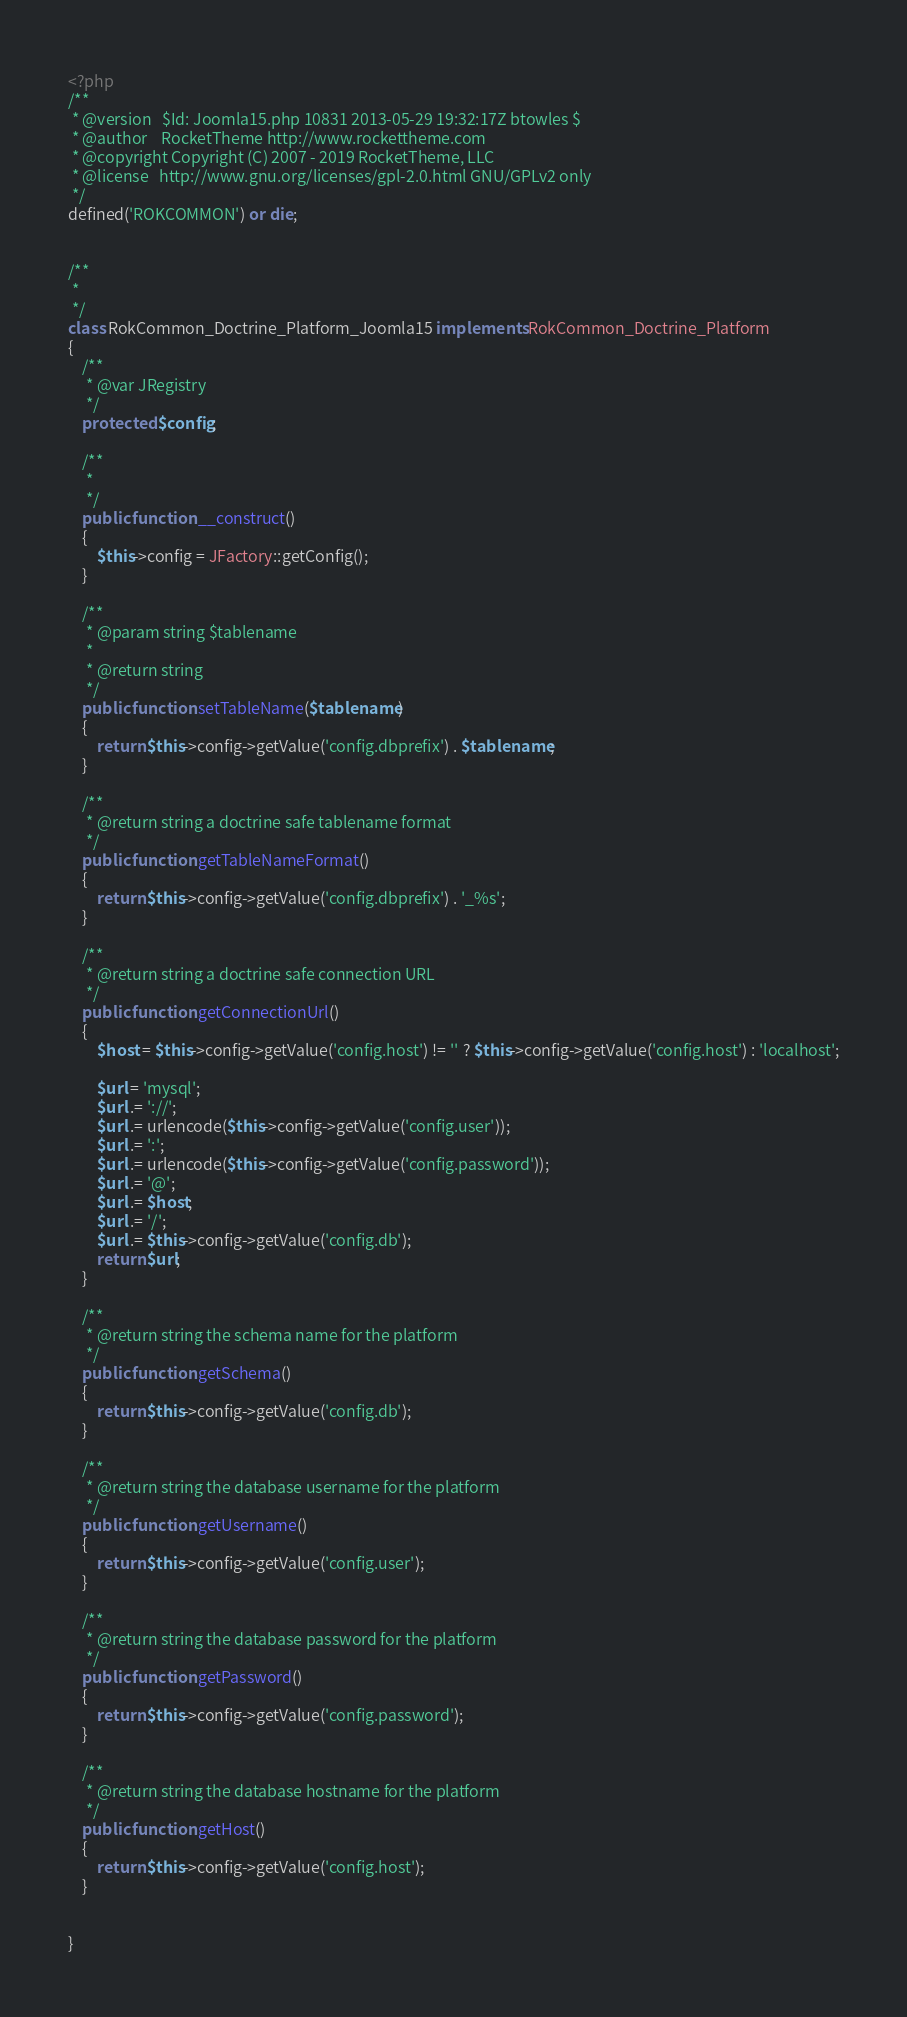<code> <loc_0><loc_0><loc_500><loc_500><_PHP_><?php
/**
 * @version   $Id: Joomla15.php 10831 2013-05-29 19:32:17Z btowles $
 * @author    RocketTheme http://www.rockettheme.com
 * @copyright Copyright (C) 2007 - 2019 RocketTheme, LLC
 * @license   http://www.gnu.org/licenses/gpl-2.0.html GNU/GPLv2 only
 */
defined('ROKCOMMON') or die;


/**
 *
 */
class RokCommon_Doctrine_Platform_Joomla15 implements RokCommon_Doctrine_Platform
{
	/**
	 * @var JRegistry
	 */
	protected $config;

	/**
	 *
	 */
	public function __construct()
	{
		$this->config = JFactory::getConfig();
	}

	/**
	 * @param string $tablename
	 *
	 * @return string
	 */
	public function setTableName($tablename)
	{
		return $this->config->getValue('config.dbprefix') . $tablename;
	}

	/**
	 * @return string a doctrine safe tablename format
	 */
	public function getTableNameFormat()
	{
		return $this->config->getValue('config.dbprefix') . '_%s';
	}

	/**
	 * @return string a doctrine safe connection URL
	 */
	public function getConnectionUrl()
	{
		$host = $this->config->getValue('config.host') != '' ? $this->config->getValue('config.host') : 'localhost';

		$url = 'mysql';
		$url .= '://';
		$url .= urlencode($this->config->getValue('config.user'));
		$url .= ':';
		$url .= urlencode($this->config->getValue('config.password'));
		$url .= '@';
		$url .= $host;
		$url .= '/';
		$url .= $this->config->getValue('config.db');
		return $url;
	}

	/**
	 * @return string the schema name for the platform
	 */
	public function getSchema()
	{
		return $this->config->getValue('config.db');
	}

	/**
	 * @return string the database username for the platform
	 */
	public function getUsername()
	{
		return $this->config->getValue('config.user');
	}

	/**
	 * @return string the database password for the platform
	 */
	public function getPassword()
	{
		return $this->config->getValue('config.password');
	}

	/**
	 * @return string the database hostname for the platform
	 */
	public function getHost()
	{
		return $this->config->getValue('config.host');
	}


}
</code> 